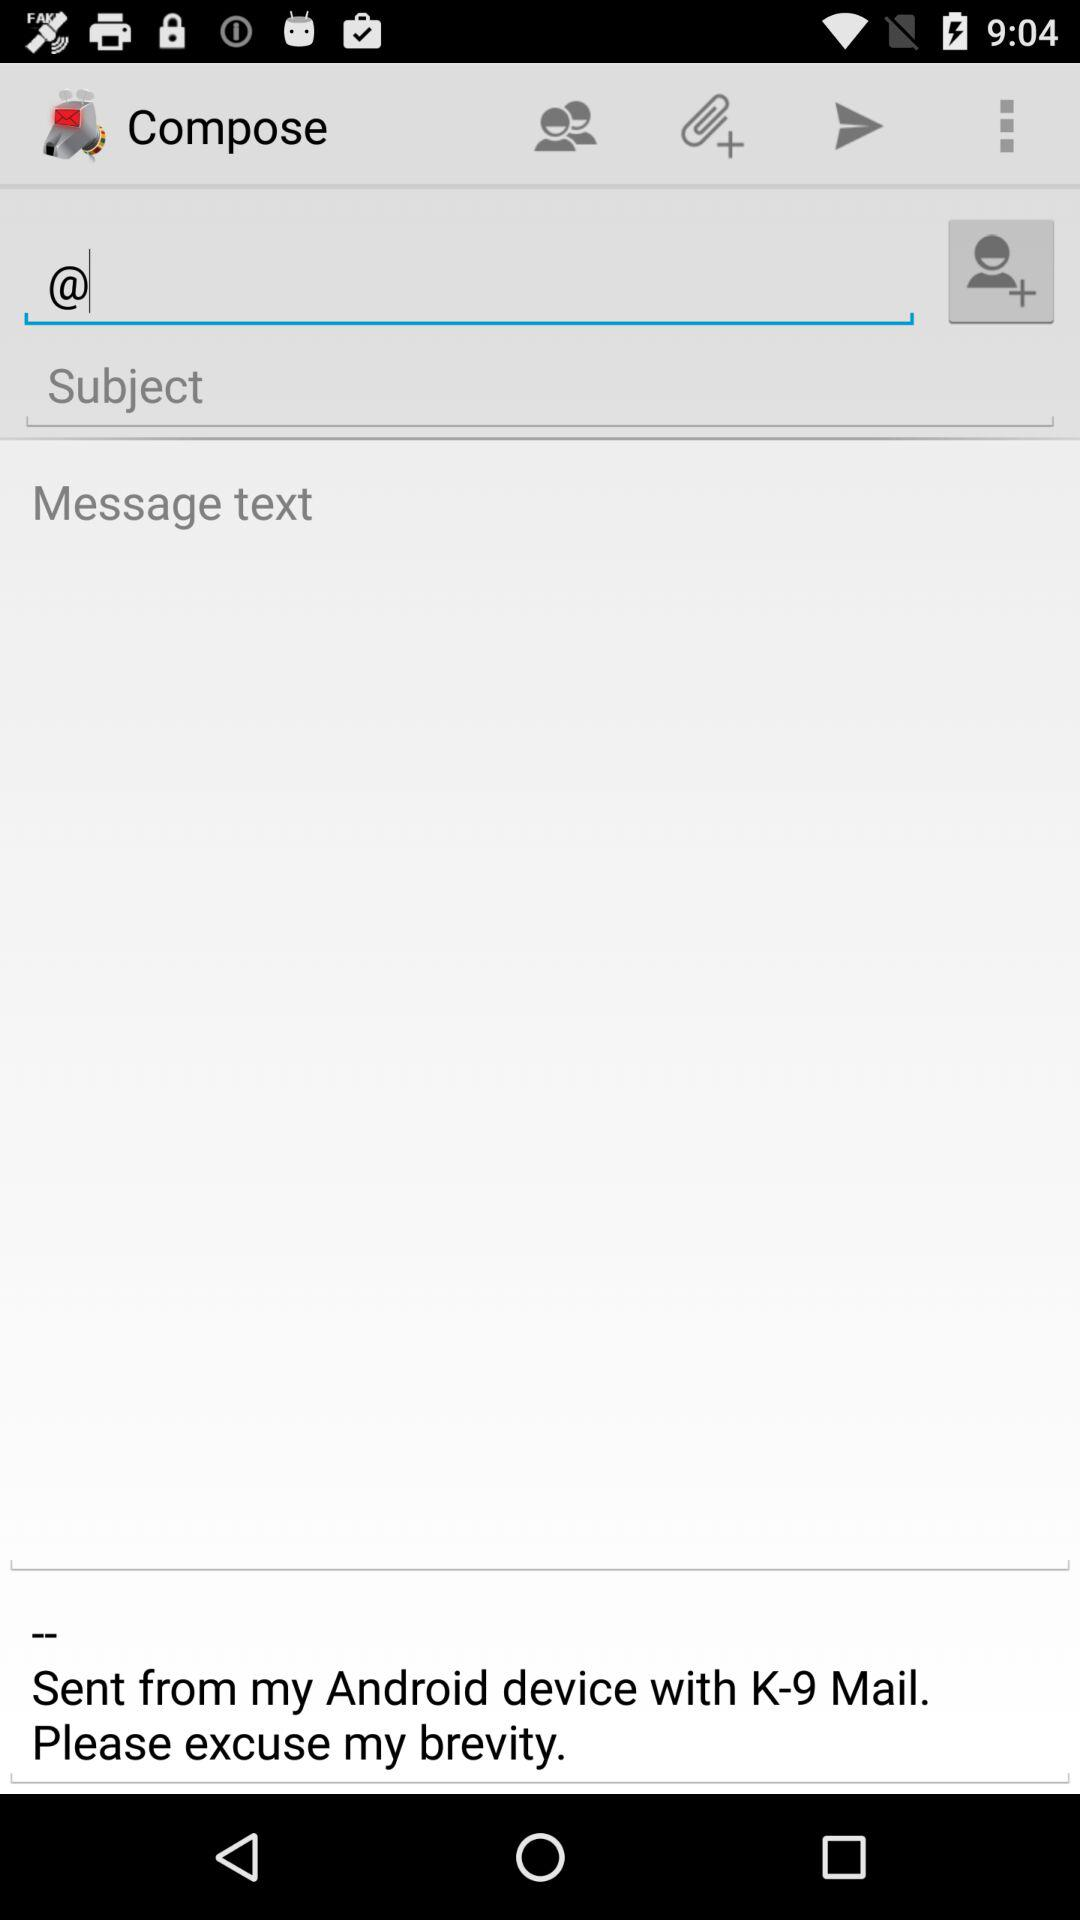What is the application name? The application name is "Compose". 